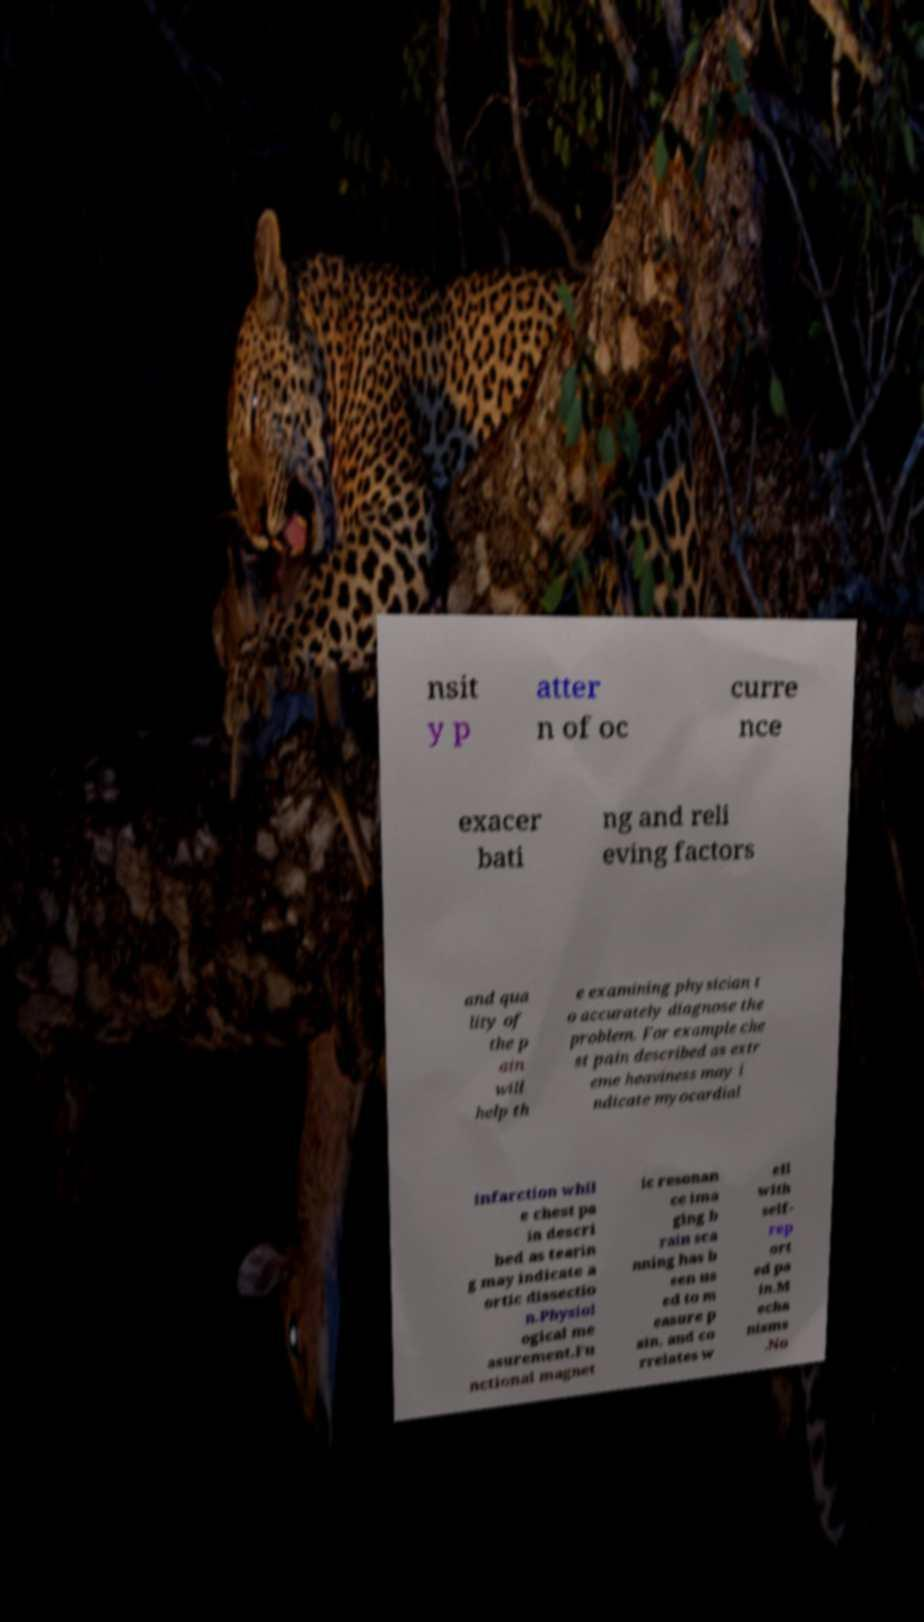Can you read and provide the text displayed in the image?This photo seems to have some interesting text. Can you extract and type it out for me? nsit y p atter n of oc curre nce exacer bati ng and reli eving factors and qua lity of the p ain will help th e examining physician t o accurately diagnose the problem. For example che st pain described as extr eme heaviness may i ndicate myocardial infarction whil e chest pa in descri bed as tearin g may indicate a ortic dissectio n.Physiol ogical me asurement.Fu nctional magnet ic resonan ce ima ging b rain sca nning has b een us ed to m easure p ain, and co rrelates w ell with self- rep ort ed pa in.M echa nisms .No 